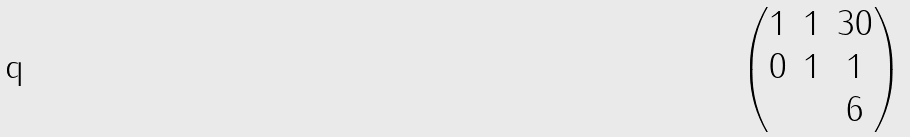<formula> <loc_0><loc_0><loc_500><loc_500>\begin{pmatrix} 1 & 1 & 3 0 \\ 0 & 1 & 1 \\ & & 6 \end{pmatrix}</formula> 